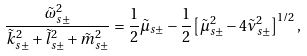Convert formula to latex. <formula><loc_0><loc_0><loc_500><loc_500>\frac { \tilde { \omega } _ { s \pm } ^ { 2 } } { \tilde { k } _ { s \pm } ^ { 2 } + \tilde { l } _ { s \pm } ^ { 2 } + \tilde { m } _ { s \pm } ^ { 2 } } = \frac { 1 } { 2 } \tilde { \mu } _ { s \pm } - \frac { 1 } { 2 } \left [ \tilde { \mu } _ { s \pm } ^ { 2 } - 4 \tilde { \nu } _ { s \pm } ^ { 2 } \right ] ^ { 1 / 2 } ,</formula> 